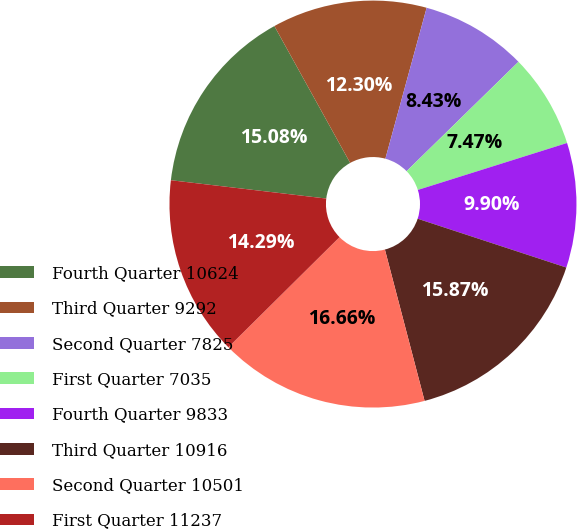Convert chart to OTSL. <chart><loc_0><loc_0><loc_500><loc_500><pie_chart><fcel>Fourth Quarter 10624<fcel>Third Quarter 9292<fcel>Second Quarter 7825<fcel>First Quarter 7035<fcel>Fourth Quarter 9833<fcel>Third Quarter 10916<fcel>Second Quarter 10501<fcel>First Quarter 11237<nl><fcel>15.08%<fcel>12.3%<fcel>8.43%<fcel>7.47%<fcel>9.9%<fcel>15.87%<fcel>16.66%<fcel>14.29%<nl></chart> 